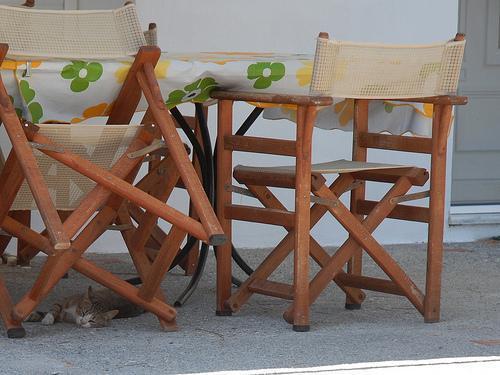How many chairs are there?
Give a very brief answer. 2. How many different color flowers are there?
Give a very brief answer. 3. 